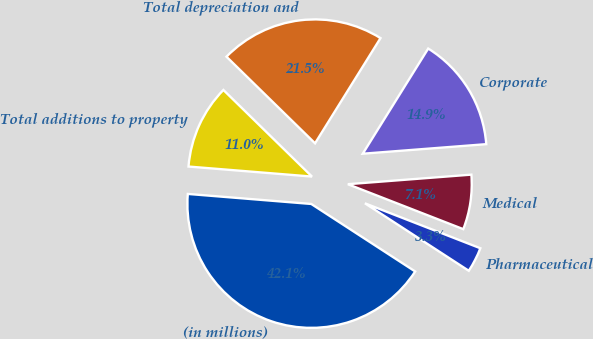<chart> <loc_0><loc_0><loc_500><loc_500><pie_chart><fcel>(in millions)<fcel>Pharmaceutical<fcel>Medical<fcel>Corporate<fcel>Total depreciation and<fcel>Total additions to property<nl><fcel>42.12%<fcel>3.26%<fcel>7.14%<fcel>14.91%<fcel>21.54%<fcel>11.03%<nl></chart> 